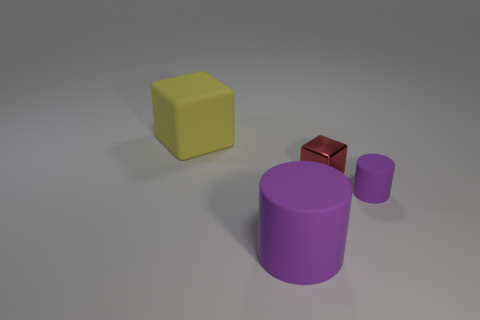Add 4 small purple blocks. How many objects exist? 8 Subtract all tiny purple rubber cylinders. Subtract all large rubber cylinders. How many objects are left? 2 Add 1 small red metallic things. How many small red metallic things are left? 2 Add 4 big matte things. How many big matte things exist? 6 Subtract 0 blue cylinders. How many objects are left? 4 